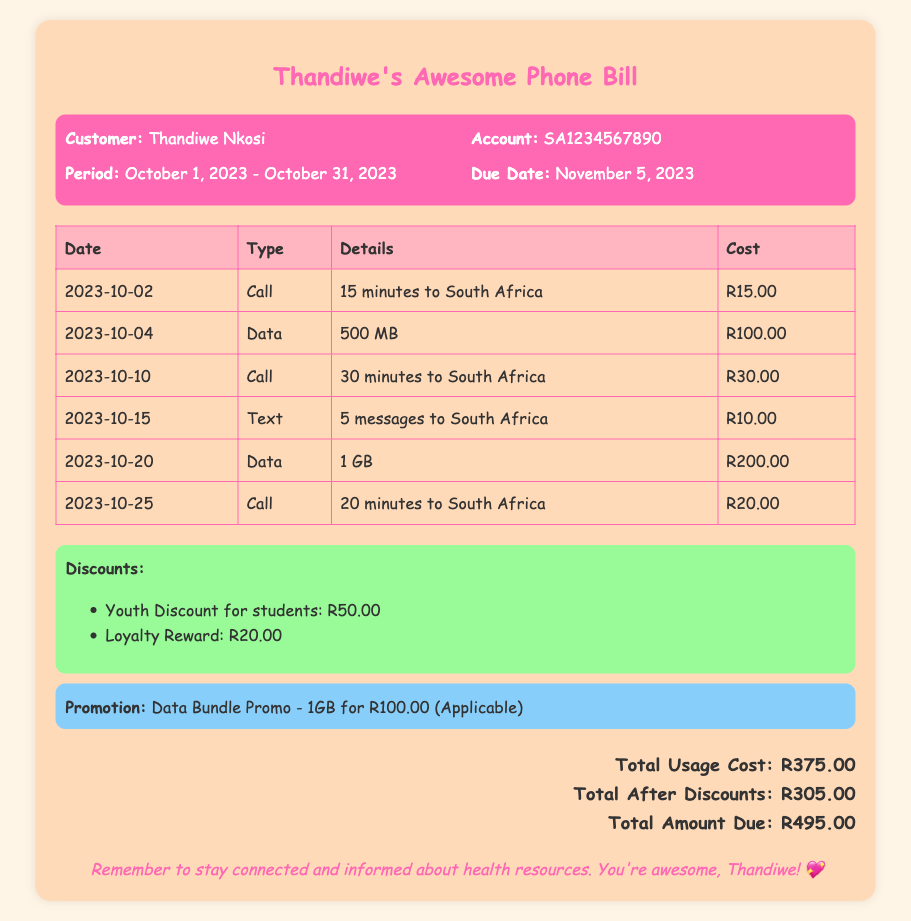What is the customer's name? The customer's name is clearly stated in the document as "Thandiwe Nkosi."
Answer: Thandiwe Nkosi What is the account number? The account number is displayed in the document as "SA1234567890."
Answer: SA1234567890 What is the total usage cost? The total usage cost is mentioned and calculated as "R375.00" in the document.
Answer: R375.00 What discounts are applied to the bill? The discounts listed in the document include "Youth Discount for students" and "Loyalty Reward."
Answer: Youth Discount for students, Loyalty Reward What is the total amount due? The total amount due is specified in the document as "R495.00."
Answer: R495.00 How many minutes were used for calls in total? Total call usage can be determined by adding the minutes: 15 + 30 + 20 = 65.
Answer: 65 minutes What is the date range of this bill? The date range for the bill is provided as "October 1, 2023 - October 31, 2023."
Answer: October 1, 2023 - October 31, 2023 What type of promotion is mentioned? The document specifies a "Data Bundle Promo" for data.
Answer: Data Bundle Promo How much is the Youth Discount? The document explicitly states the Youth Discount amount as "R50.00."
Answer: R50.00 